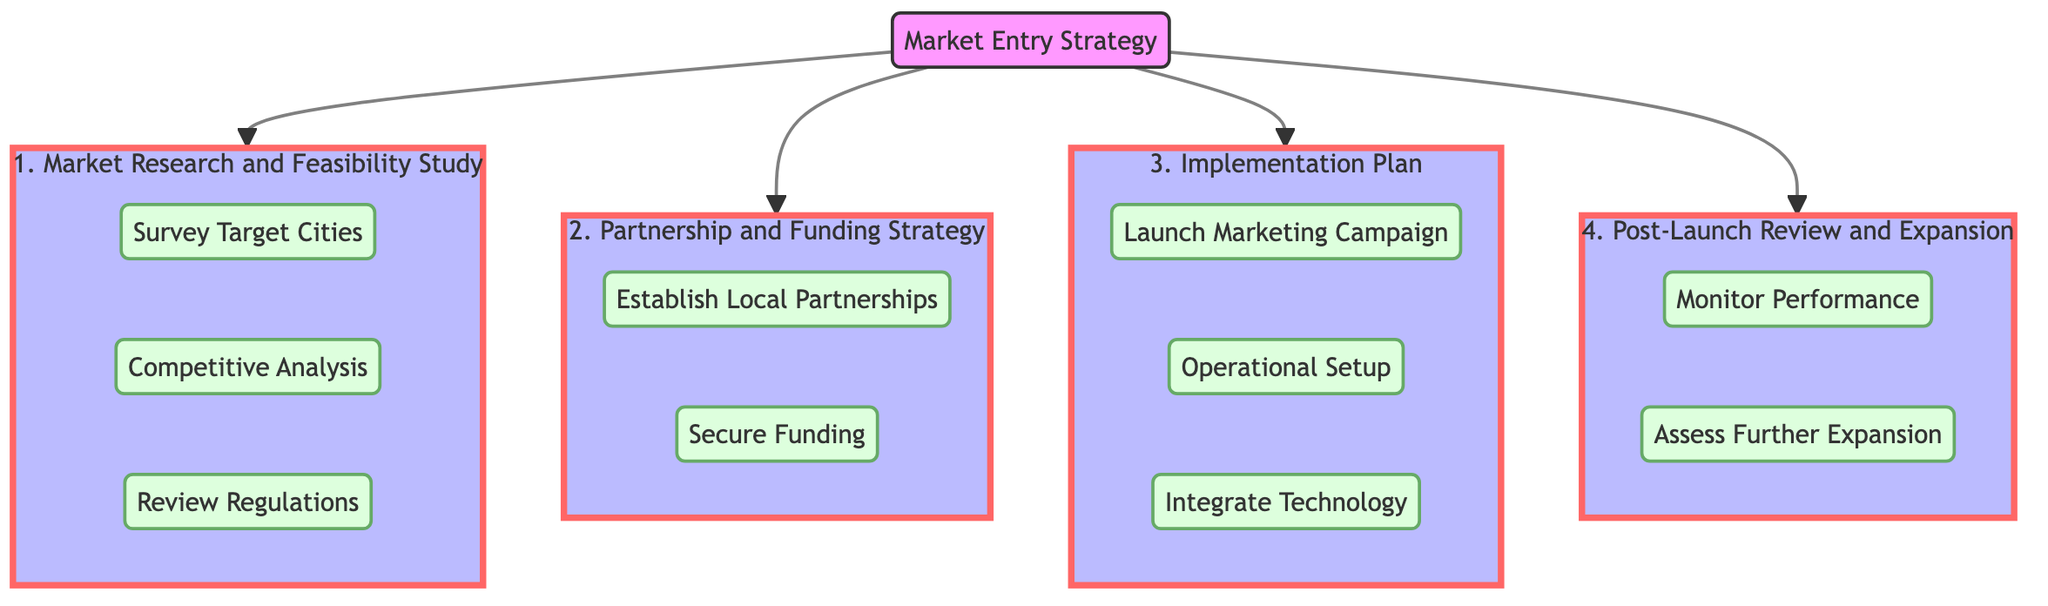What is the first step in the Market Entry Strategy? The first step in the Market Entry Strategy is found at the top of the flow chart leading into the first step box, which is labeled "Market Research and Feasibility Study."
Answer: Market Research and Feasibility Study How many substeps are in Step 2? By examining Step 2 in the flow chart, we see it contains two substeps, which can be counted: "Establish Local Partnerships" and "Secure Funding."
Answer: 2 What are the names of the substeps in Step 1? To find the names of the substeps in Step 1, we look at the three branches under "Market Research and Feasibility Study": "Survey Target Cities," "Competitive Analysis," and "Review Regulations."
Answer: Survey Target Cities, Competitive Analysis, Review Regulations Which step includes "Integrate Technology"? Looking through the flowchart, "Integrate Technology" is found as a substep in Step 3, which is labeled "Implementation Plan."
Answer: Implementation Plan What is the last substep in the Market Entry Strategy? The last substep in the diagram is "Assess Further Expansion," which is located within Step 4, labeled "Post-Launch Review and Expansion."
Answer: Assess Further Expansion How many main steps are in the Market Entry Strategy? Counting the main steps shown at the top of the diagram, we find that there are four distinct steps: Step 1, Step 2, Step 3, and Step 4.
Answer: 4 What flows from "Secure Funding"? From the substep "Secure Funding," there are no additional steps flowing out; hence, it is not followed by any nodes or substeps in this diagram.
Answer: None What does "Monitor Performance" involve? "Monitor Performance," a substep under Step 4, involves tracking key performance indicators, gathering customer feedback, and analyzing operational data to make improvements.
Answer: Tracking KPIs, gathering feedback, analyzing data 